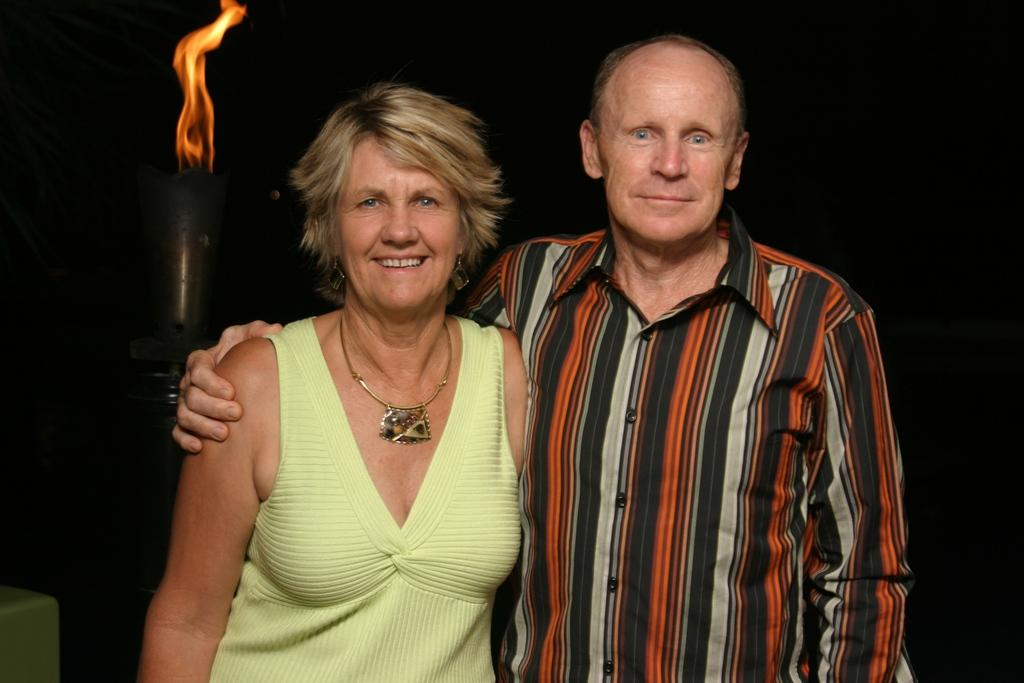How many people are in the image? There are two people in the image, a man and a woman. What are the man and woman doing in the image? The man and woman are standing. What can be seen in the background of the image? There is a lamp in the background of the image. What is the lamp doing in the image? The lamp has fire in it. What type of goose is sitting on the notebook in the image? There is no goose or notebook present in the image. What is the governor's opinion on the situation depicted in the image? There is no reference to a governor or any opinions in the image. 